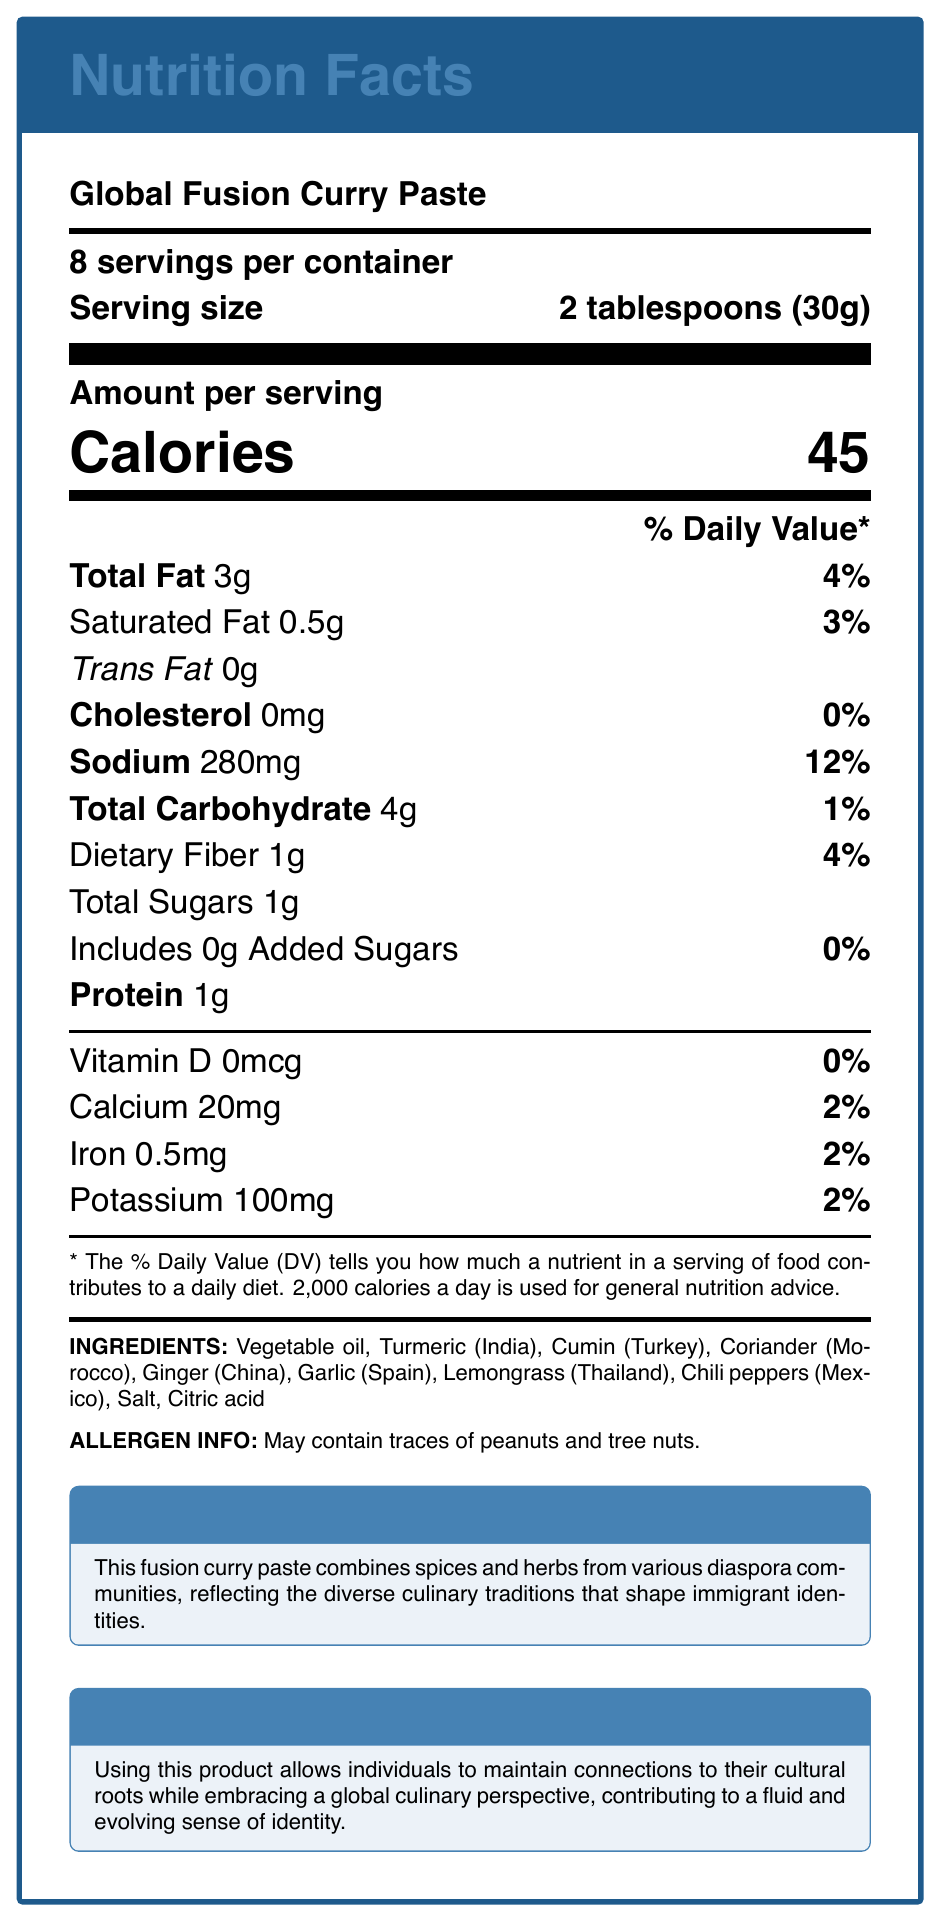what is the serving size of the Global Fusion Curry Paste? The document specifies that the serving size is 2 tablespoons or 30 grams.
Answer: 2 tablespoons (30g) how many servings are there per container of the Global Fusion Curry Paste? The document lists that there are 8 servings per container.
Answer: 8 how much sodium is in each serving? The document shows that there are 280mg of sodium per serving.
Answer: 280mg what is the percentage daily value of dietary fiber in each serving? The document states that the daily value percentage for dietary fiber is 4% per serving.
Answer: 4% how many grams of total fat are in a serving? The document details that a serving contains 3 grams of total fat.
Answer: 3g which countries are the ingredients turmeric and cumin sourced from? A. India and Turkey B. Morocco and China C. Spain and Thailand D. Mexico and Thailand The document indicates that turmeric is sourced from India, and cumin is sourced from Turkey.
Answer: A what is the total percentage daily value of iron in a serving? The document indicates that the daily value percentage for iron is 2%.
Answer: 2% this product is low in saturated fat. True or False? The document emphasizes "Low in saturated fat" as a nutritional highlight.
Answer: True cannot this product contain any added sugars? The document shows that there are no added sugars in this product.
Answer: 0g which ingredient is not listed as part of this product? A. Vegetable oil B. Cinnamon C. Lemongrass D. Garlic Cinnamon is not listed among the ingredients, while the others are.
Answer: B describe the main purpose and content of the document. The document serves as a comprehensive nutrition and ingredient guide for a fusion curry paste product, emphasizing its global and cultural connections.
Answer: The document provides a nutrition facts label for the "Global Fusion Curry Paste," detailing serving size, servings per container, calories, and various nutrient amounts with their daily values. It also lists the ingredients sourced from different countries, allergen information, along with notes on cultural significance, identity impact, and sustainability. what is the significance of the document in terms of identity impact? The document mentions that the product helps individuals maintain cultural connections while adopting a global culinary outlook, thus influencing a dynamic sense of identity.
Answer: Using this product allows individuals to maintain connections to their cultural roots while embracing a global culinary perspective, contributing to a fluid and evolving sense of identity. who created the Global Fusion Curry Paste product? The given visual document does not include any information about who created the product.
Answer: Cannot be determined 